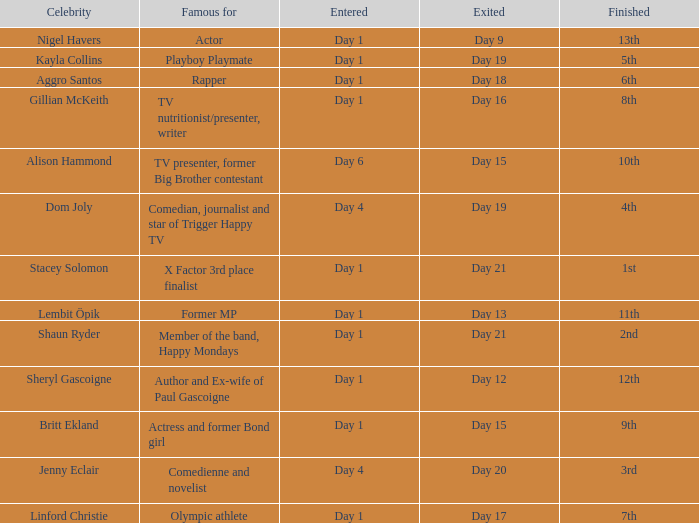What celebrity is famous for being an actor? Nigel Havers. 